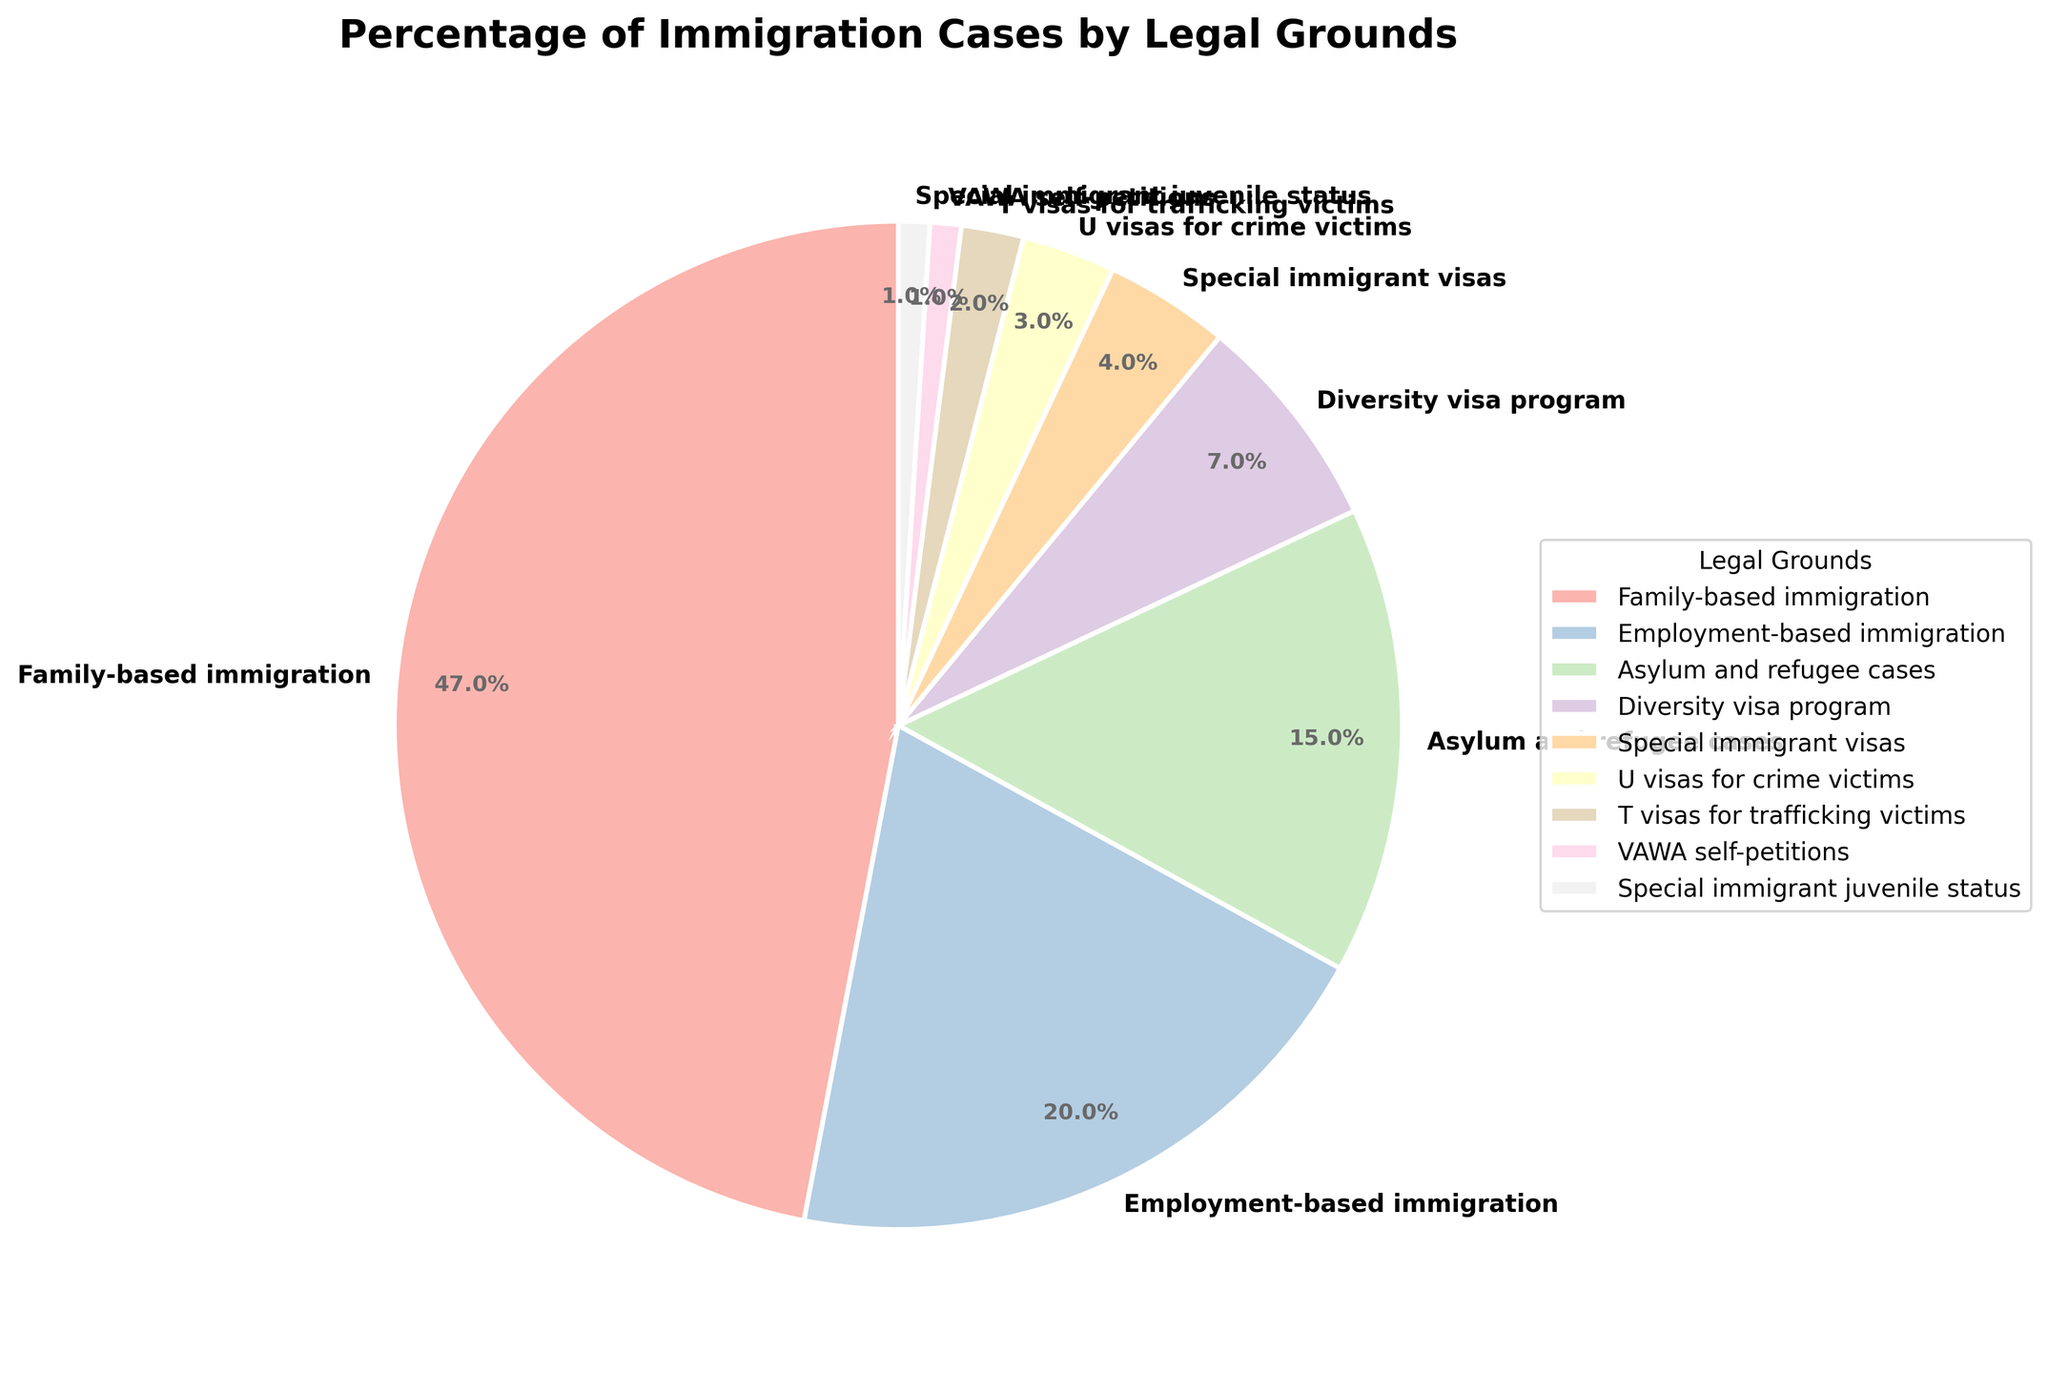Which legal grounds have the highest percentage of immigration cases? By looking at the pie chart, the segment with the largest size, marked as "family-based immigration," shows the highest percentage.
Answer: Family-based immigration Which legal grounds contribute the least to the percentage of immigration cases? The smallest segment in the pie chart, labeled "Special immigrant juvenile status" and "VAWA self-petitions," show the lowest percentage.
Answer: Special immigrant juvenile status and VAWA self-petitions What is the combined percentage of immigration cases for U visas for crime victims and T visas for trafficking victims? Add the percentage of U visas for crime victims (3%) and T visas for trafficking victims (2%). The sum is 3% + 2%.
Answer: 5% How much more prevalent are family-based immigration cases compared to employment-based immigration cases? Subtract the percentage of employment-based immigration cases (20%) from the percentage of family-based immigration cases (47%). The difference is 47% - 20%.
Answer: 27% What percentage of immigration cases are based on asylum and refugee cases and diversity visa program combined? Add the percentage of asylum and refugee cases (15%) to the percentage of diversity visa program cases (7%). The sum is 15% + 7%.
Answer: 22% Is employment-based immigration contributing more or less than a quarter of the total immigration cases? A quarter of the total is 25%. The employment-based immigration percentage is 20%, which is less than 25%.
Answer: Less How does the percentage of employment-based immigration cases compare to the combined percentage of special immigrant visas and U visas for crime victims? Add the percentage for special immigrant visas (4%) and U visas for crime victims (3%). The sum is 4% + 3% = 7%. Then, compare it with the percentage for employment-based immigration (20%), which is greater.
Answer: Employment-based immigration is greater What is the total percentage of immigration cases attributed to special categories (Special immigrant visas, U visas for crime victims, T visas for trafficking victims, VAWA self-petitions, Special immigrant juvenile status)? Add the percentages of these categories: 4% (Special immigrant visas) + 3% (U visas for crime victims) + 2% (T visas for trafficking victims) + 1% (VAWA self-petitions) + 1% (Special immigrant juvenile status). The sum is 4% + 3% + 2% + 1% + 1%.
Answer: 11% Are special immigrant juvenile status and VAWA self-petitions equally distributed in the percentage of immigration cases? Both segments for special immigrant juvenile status and VAWA self-petitions have 1% each, indicating an equal distribution.
Answer: Yes What is the difference in percentage between asylum and refugee cases and diversity visa program cases? Subtract the percentage of diversity visa program cases (7%) from the percentage of asylum and refugee cases (15%). The difference is 15% - 7%.
Answer: 8% 